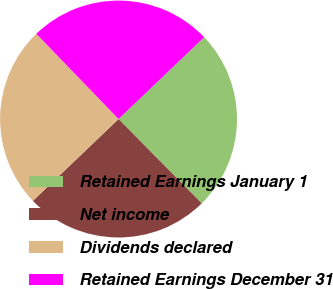<chart> <loc_0><loc_0><loc_500><loc_500><pie_chart><fcel>Retained Earnings January 1<fcel>Net income<fcel>Dividends declared<fcel>Retained Earnings December 31<nl><fcel>24.75%<fcel>25.25%<fcel>24.92%<fcel>25.08%<nl></chart> 